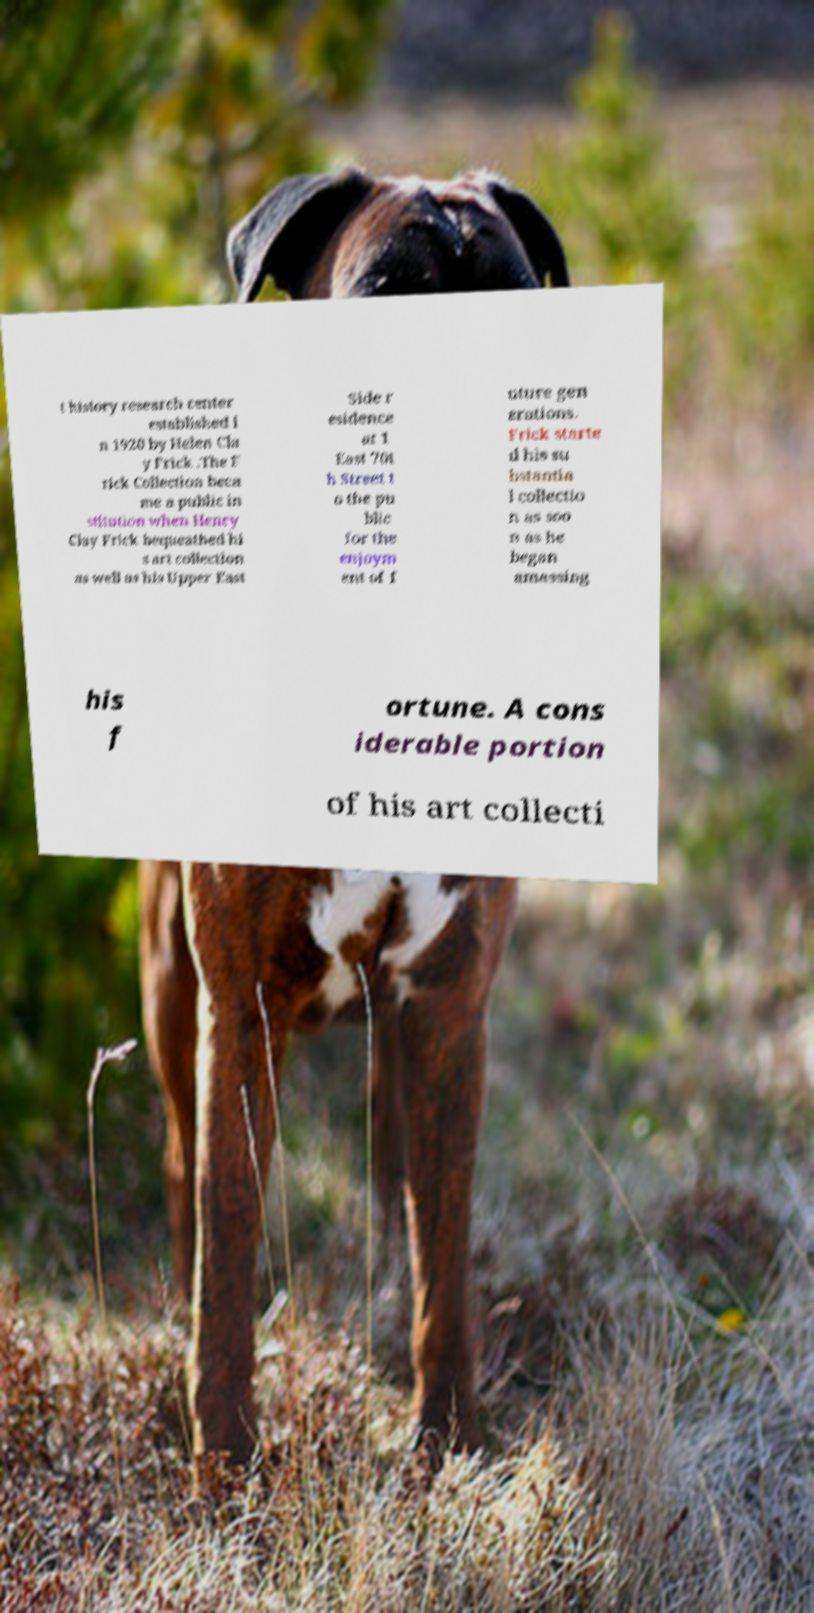Could you assist in decoding the text presented in this image and type it out clearly? t history research center established i n 1920 by Helen Cla y Frick .The F rick Collection beca me a public in stitution when Henry Clay Frick bequeathed hi s art collection as well as his Upper East Side r esidence at 1 East 70t h Street t o the pu blic for the enjoym ent of f uture gen erations. Frick starte d his su bstantia l collectio n as soo n as he began amassing his f ortune. A cons iderable portion of his art collecti 